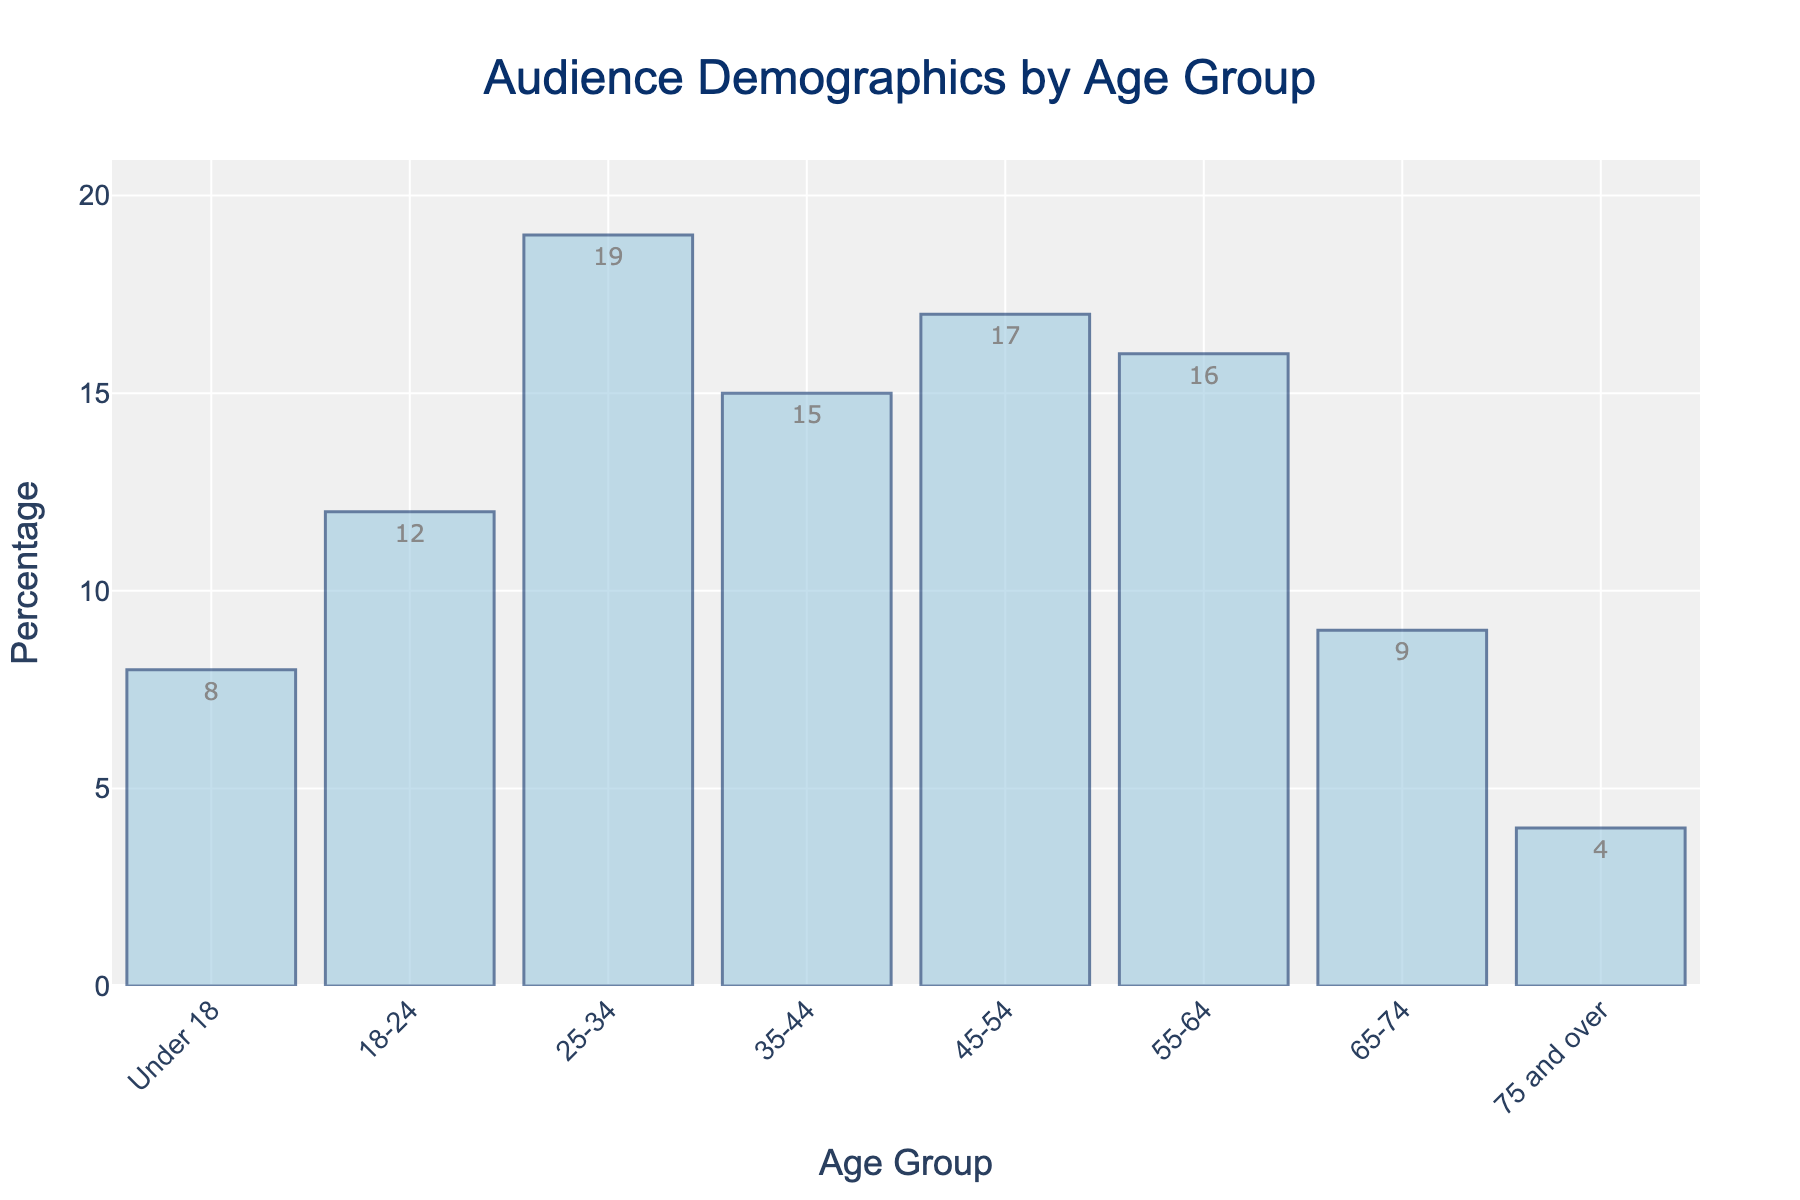Which age group has the highest percentage of audience members? Look at the bar corresponding to each age group and observe which is tallest. The tallest bar represents the 25-34 age group.
Answer: 25-34 What is the difference between the percentage of audience members in the 25-34 and 75 and over age groups? Check the bars for the 25-34 and 75 and over age groups, noting the percentages. The 25-34 group has 19%, and the 75 and over group has 4%. Subtracting these gives 19% - 4% = 15%.
Answer: 15% How many age groups have a percentage of 15% or more? Identify all bars with percentages of 15% or higher, totaling the qualifying age groups. The age groups are 25-34 (19%), 35-44 (15%), 45-54 (17%), and 55-64 (16%). So there are 4 age groups.
Answer: 4 Which age group has the smallest percentage of audience members? Identify the shortest bar, which represents the 75 and over age group, with 4%.
Answer: 75 and over What is the combined percentage of audience members under 18 and between 18-24? Check the bars for both Under 18 and 18-24 groups, and sum their percentages. Under 18 has 8%, and 18-24 has 12%. Adding these gives 8% + 12% = 20%.
Answer: 20% How does the percentage of audience members in the 45-54 age group compare to the 55-64 age group? Compare the heights of the bars for the 45-54 and 55-64 age groups. The 45-54 group has 17%, and the 55-64 group has 16%. Thus, the 45-54 group is 1% higher than the 55-64 group.
Answer: 45-54 is 1% higher What is the average percentage of audience members for the age groups 25-34, 35-44, and 45-54? Identify the percentages for these groups: 25-34 (19%), 35-44 (15%), and 45-54 (17%). Sum these values and divide by the number of groups: (19 + 15 + 17) / 3 = 51 / 3 = 17%.
Answer: 17% Which age group has a percentage closest to 10%? Compare the percentages to 10%, identifying the age group with the closest value. The 65-74 age group has 9%, which is the nearest.
Answer: 65-74 What is the total percentage of audience members for the age groups 55-64 and 65-74? Sum the percentages for the 55-64 and 65-74 groups: 16% + 9% = 25%.
Answer: 25% 